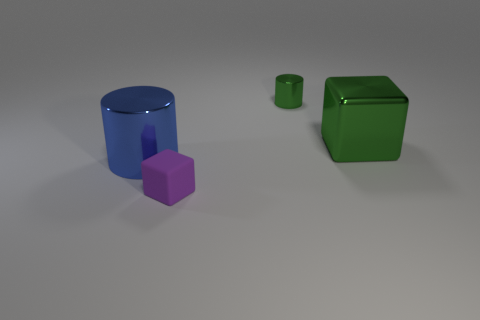Are there any tiny gray cylinders?
Offer a very short reply. No. The metal object that is on the left side of the tiny thing in front of the tiny metallic thing is what color?
Offer a terse response. Blue. There is another big object that is the same shape as the purple matte thing; what is its material?
Your answer should be very brief. Metal. How many green metallic cylinders are the same size as the blue cylinder?
Make the answer very short. 0. What is the size of the block that is the same material as the tiny cylinder?
Give a very brief answer. Large. What number of blue shiny things are the same shape as the tiny purple rubber object?
Provide a succinct answer. 0. What number of green things are there?
Provide a short and direct response. 2. Is the shape of the metal thing in front of the metal block the same as  the large green thing?
Your answer should be compact. No. There is a cube that is the same size as the blue cylinder; what material is it?
Your answer should be very brief. Metal. Are there any other cylinders that have the same material as the tiny green cylinder?
Give a very brief answer. Yes. 